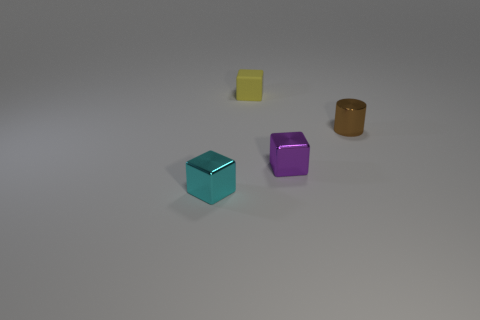Add 1 cyan things. How many objects exist? 5 Subtract all cylinders. How many objects are left? 3 Subtract all large yellow rubber balls. Subtract all tiny brown cylinders. How many objects are left? 3 Add 2 metal objects. How many metal objects are left? 5 Add 2 small purple shiny blocks. How many small purple shiny blocks exist? 3 Subtract 0 green blocks. How many objects are left? 4 